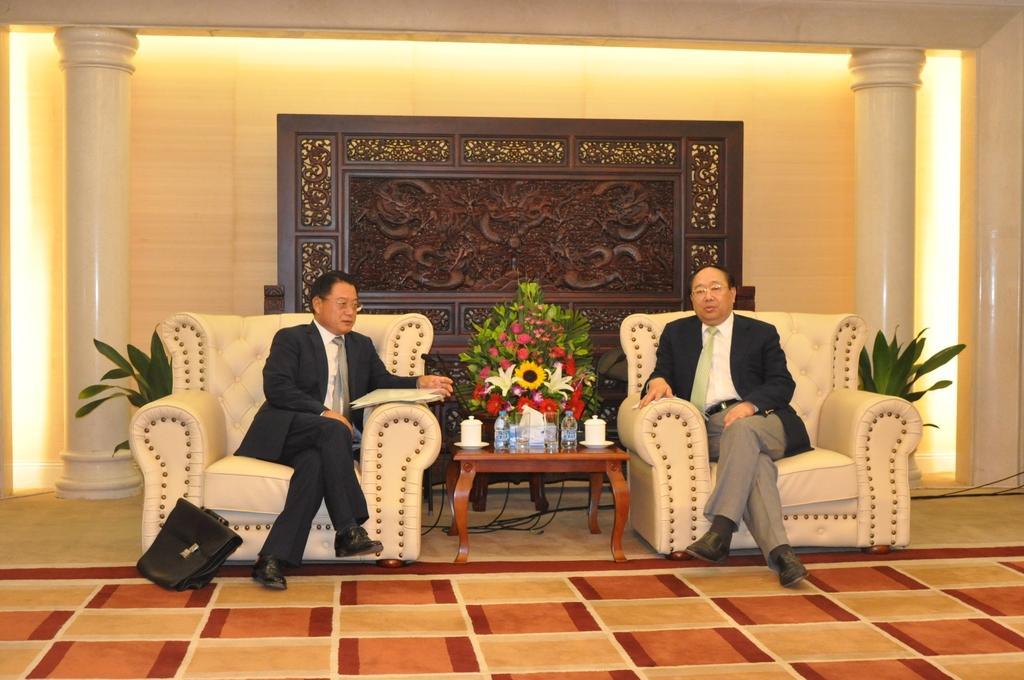How would you summarize this image in a sentence or two? In this image there are two persons sitting on the couch at the middle of the image there is a flower bouquet and table on which there are water bottles and tea cups at the background there is a brown color wooden wall 